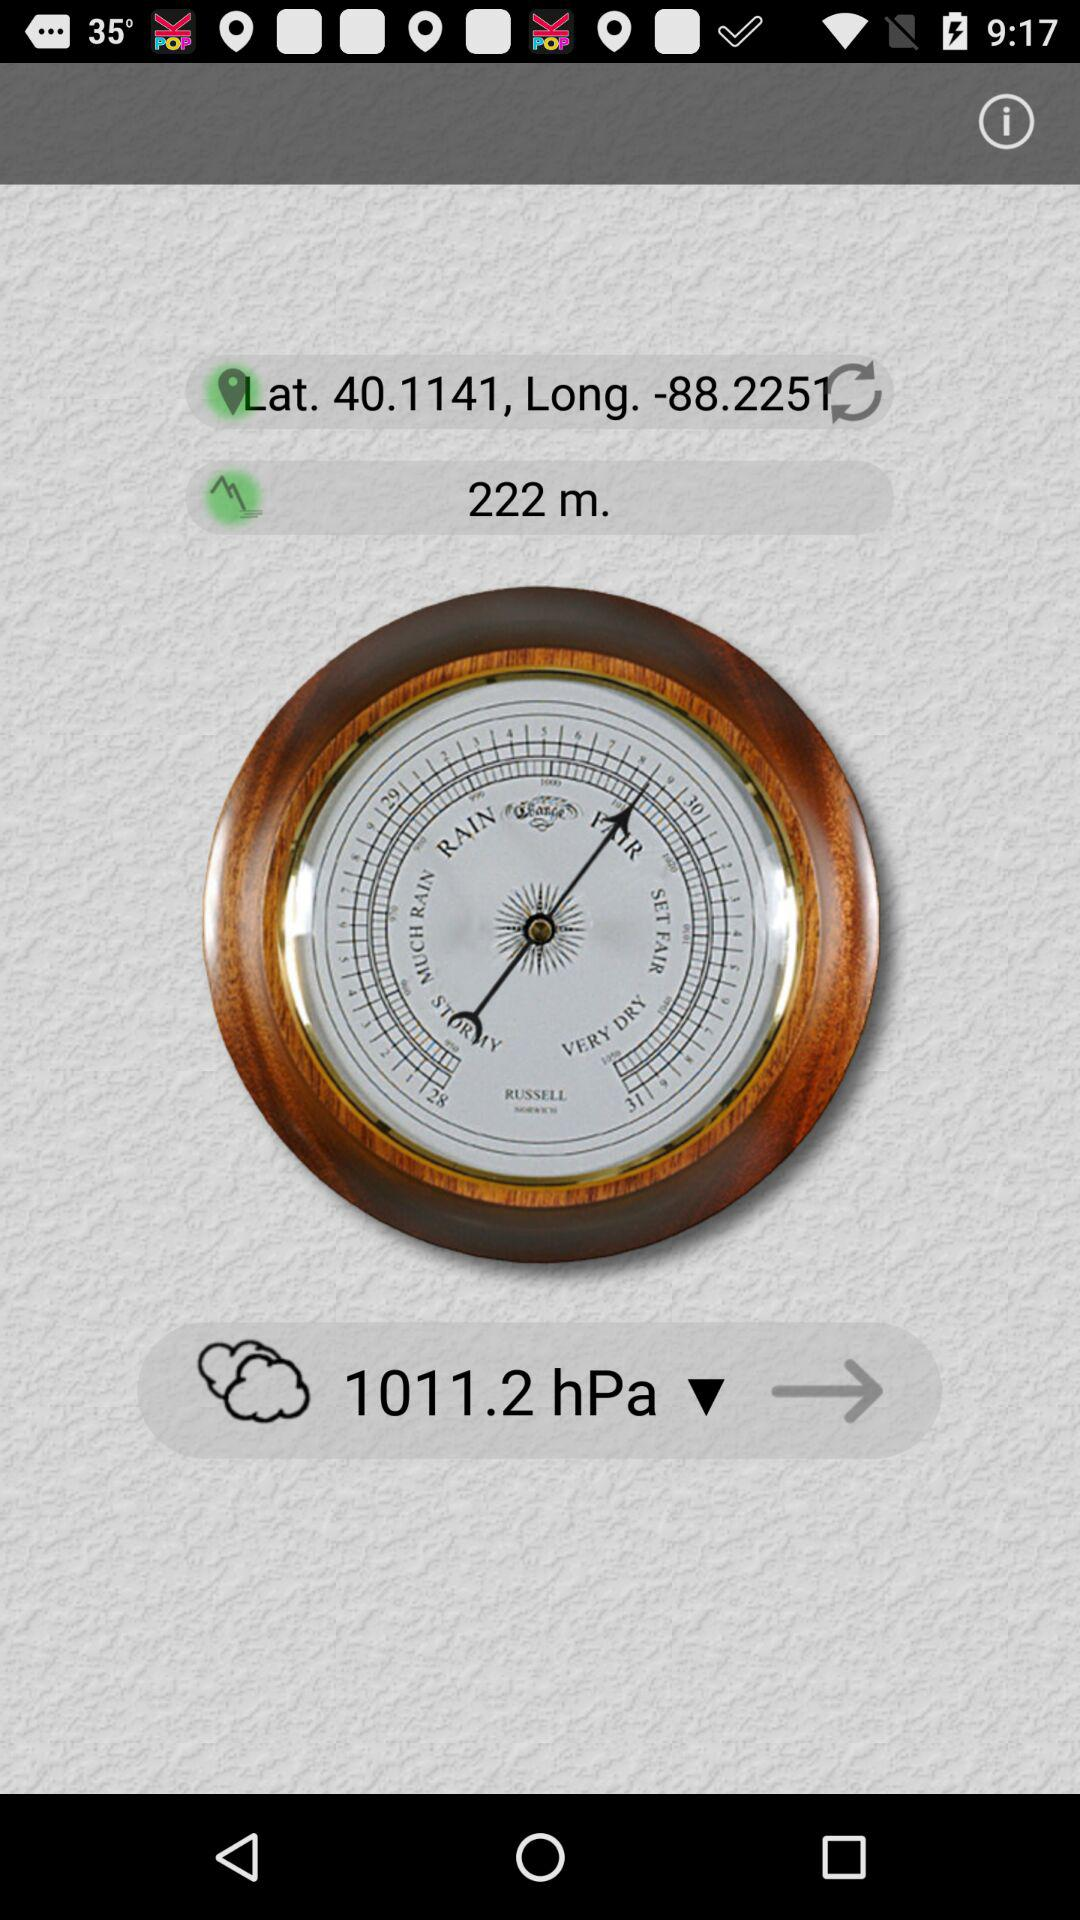What is the shown atmospheric pressure? The shown atmospheric pressure is 1011.2 hPa. 